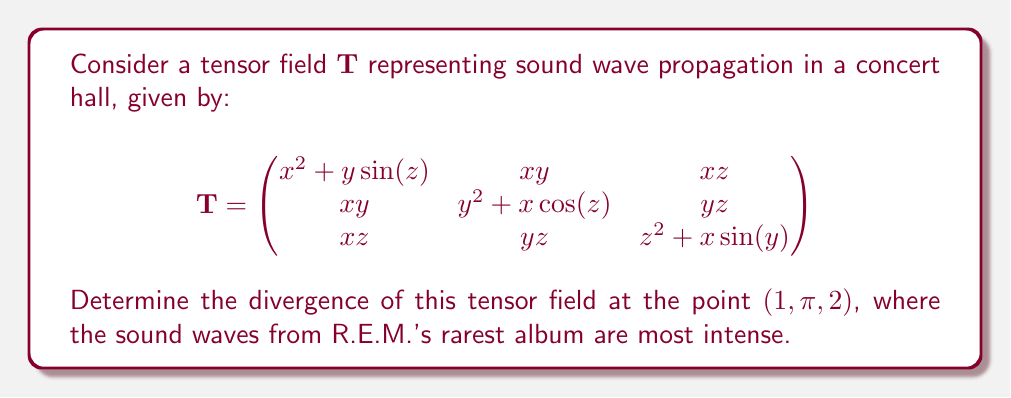What is the answer to this math problem? To find the divergence of the tensor field $\mathbf{T}$, we need to calculate the trace of its gradient. The divergence is given by:

$$\text{div}(\mathbf{T}) = \frac{\partial T_{11}}{\partial x} + \frac{\partial T_{22}}{\partial y} + \frac{\partial T_{33}}{\partial z}$$

Let's calculate each partial derivative:

1. $\frac{\partial T_{11}}{\partial x} = \frac{\partial}{\partial x}(x^2 + y\sin(z)) = 2x$

2. $\frac{\partial T_{22}}{\partial y} = \frac{\partial}{\partial y}(y^2 + x\cos(z)) = 2y$

3. $\frac{\partial T_{33}}{\partial z} = \frac{\partial}{\partial z}(z^2 + x\sin(y)) = 2z$

Now, we sum these partial derivatives:

$$\text{div}(\mathbf{T}) = 2x + 2y + 2z$$

To find the divergence at the point $(1, \pi, 2)$, we substitute these values:

$$\text{div}(\mathbf{T})_{(1,\pi,2)} = 2(1) + 2(\pi) + 2(2) = 2 + 2\pi + 4 = 2\pi + 6$$

This value represents the rate at which sound energy is spreading out from the point $(1, \pi, 2)$ in the concert hall.
Answer: $2\pi + 6$ 